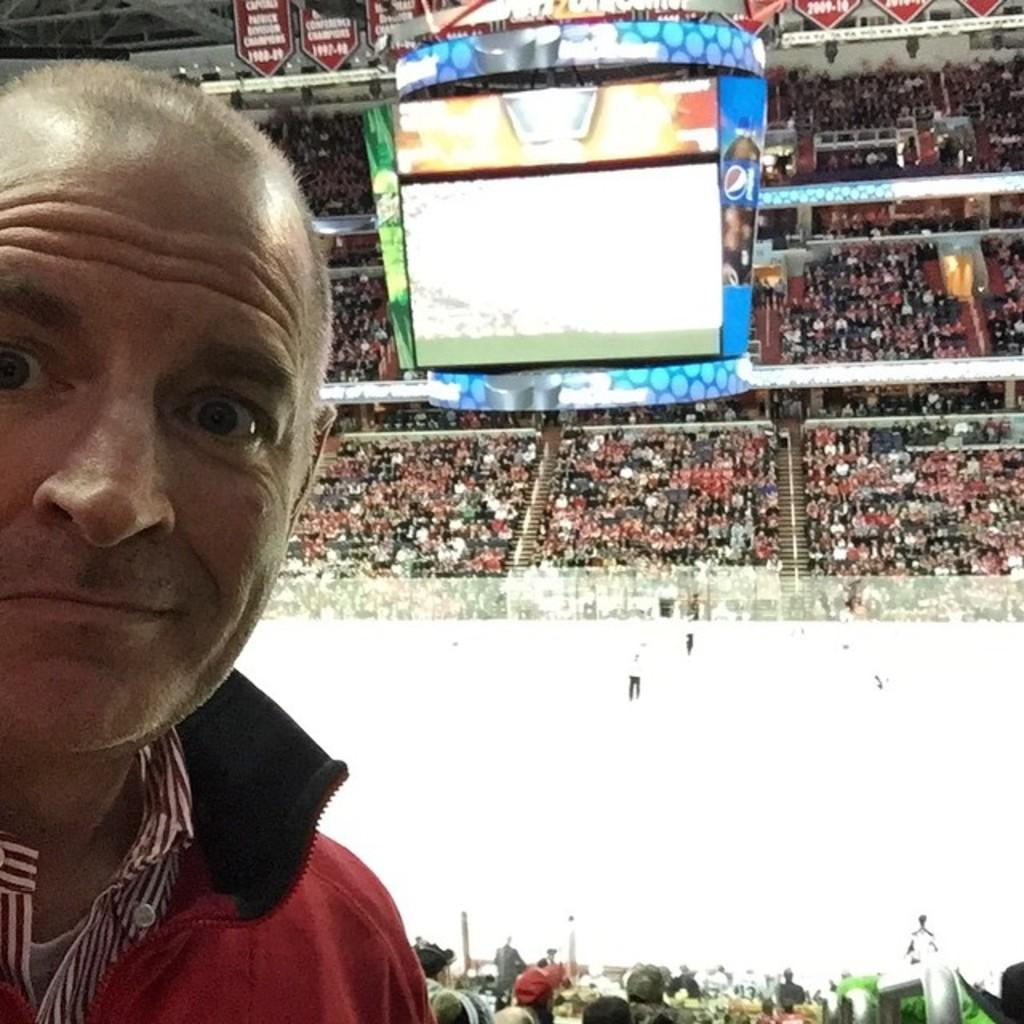What type of location is depicted in the image? The image is of a stadium. What can be seen in the stadium? There is a crowd in the image. Are there any architectural features visible in the image? Yes, there are stairs in the image. What is used for displaying information or visuals in the image? There is a screen in the image. What else is present in the image besides the crowd and the screen? There are objects and boards in the image. Can you describe the man on the left side of the image? There is a man on the left side of the image. What type of brake system is installed on the stairs in the image? There is no mention of a brake system in the image; it is a stadium with stairs, a crowd, a screen, objects, boards, and a man on the left side. Can you see any chickens running around in the image? There is no mention of chickens in the image; it is a stadium with a crowd, stairs, a screen, objects, boards, and a man on the left side. 